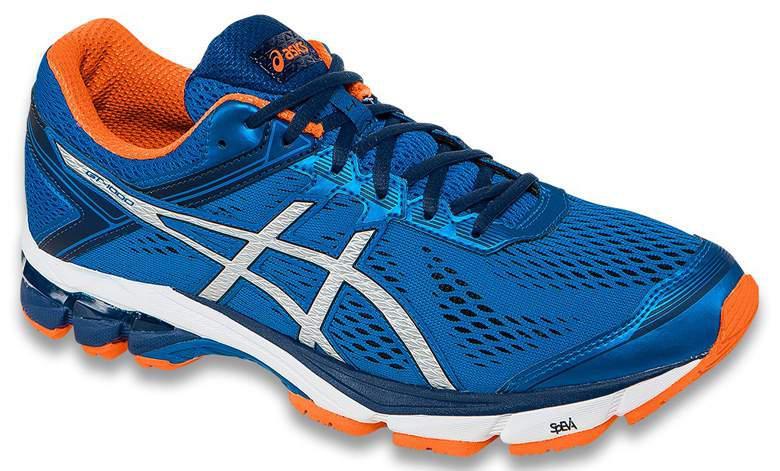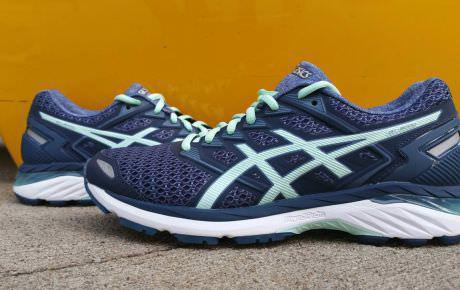The first image is the image on the left, the second image is the image on the right. Considering the images on both sides, is "The left image is a blue shoe on a white background." valid? Answer yes or no. Yes. 